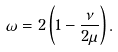Convert formula to latex. <formula><loc_0><loc_0><loc_500><loc_500>\omega = 2 \left ( 1 - \frac { \nu } { 2 \mu } \right ) .</formula> 